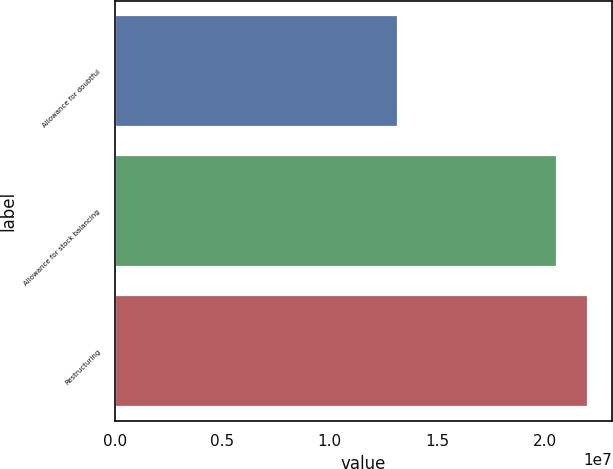<chart> <loc_0><loc_0><loc_500><loc_500><bar_chart><fcel>Allowance for doubtful<fcel>Allowance for stock balancing<fcel>Restructuring<nl><fcel>1.3181e+07<fcel>2.0578e+07<fcel>2.2002e+07<nl></chart> 